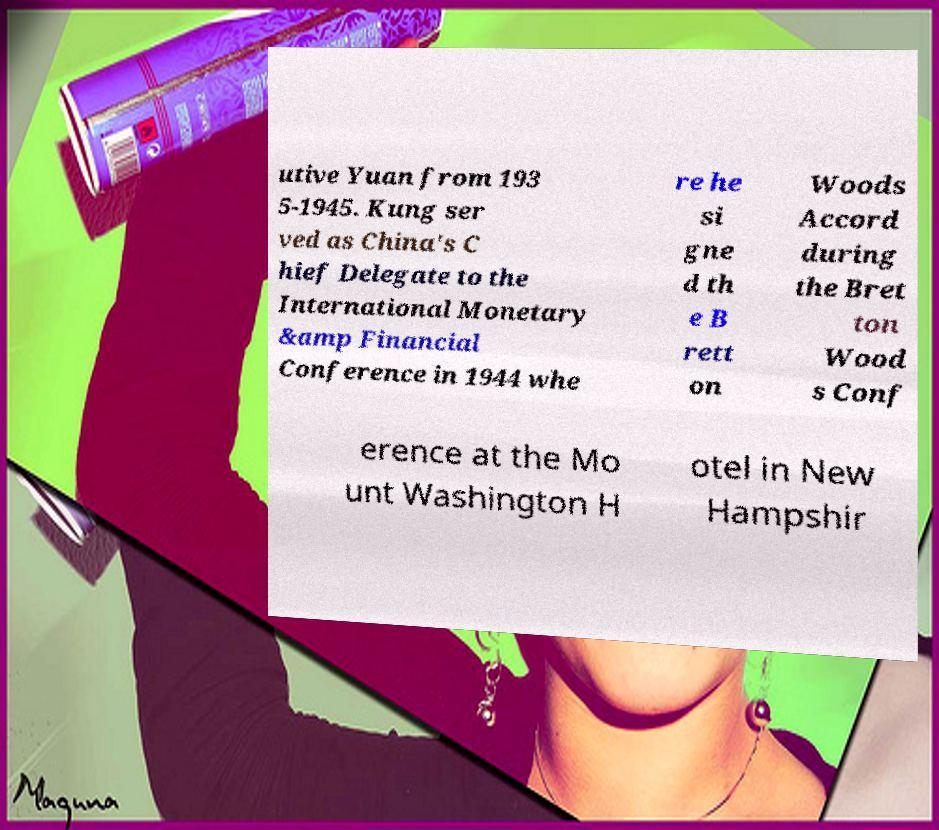Could you assist in decoding the text presented in this image and type it out clearly? utive Yuan from 193 5-1945. Kung ser ved as China's C hief Delegate to the International Monetary &amp Financial Conference in 1944 whe re he si gne d th e B rett on Woods Accord during the Bret ton Wood s Conf erence at the Mo unt Washington H otel in New Hampshir 